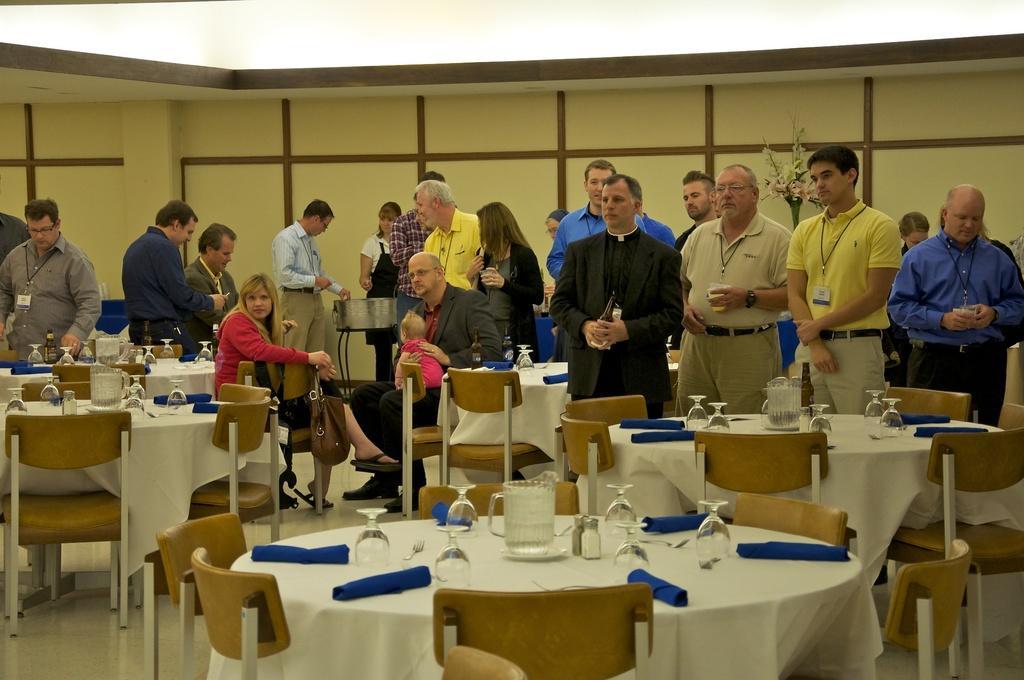Describe this image in one or two sentences. In this image we can see a few people, among them some are standing and some are sitting on the chairs, we can see few people holding the objects, in front of them, we can see some chairs and tables, on the tables we can see glasses, jugs and some other objects, in the background we can the flower vase and the wall. 